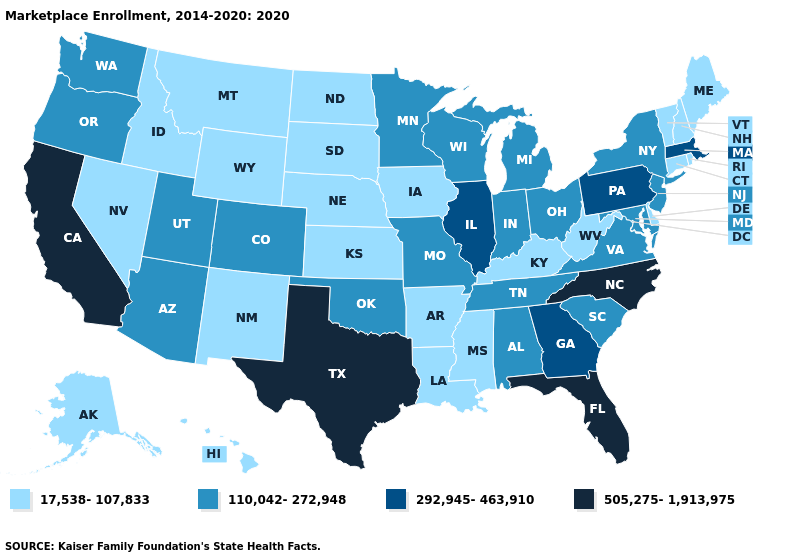Name the states that have a value in the range 505,275-1,913,975?
Answer briefly. California, Florida, North Carolina, Texas. Does the first symbol in the legend represent the smallest category?
Short answer required. Yes. Name the states that have a value in the range 17,538-107,833?
Answer briefly. Alaska, Arkansas, Connecticut, Delaware, Hawaii, Idaho, Iowa, Kansas, Kentucky, Louisiana, Maine, Mississippi, Montana, Nebraska, Nevada, New Hampshire, New Mexico, North Dakota, Rhode Island, South Dakota, Vermont, West Virginia, Wyoming. Among the states that border Wisconsin , does Iowa have the highest value?
Answer briefly. No. Name the states that have a value in the range 17,538-107,833?
Short answer required. Alaska, Arkansas, Connecticut, Delaware, Hawaii, Idaho, Iowa, Kansas, Kentucky, Louisiana, Maine, Mississippi, Montana, Nebraska, Nevada, New Hampshire, New Mexico, North Dakota, Rhode Island, South Dakota, Vermont, West Virginia, Wyoming. Among the states that border New Mexico , which have the lowest value?
Give a very brief answer. Arizona, Colorado, Oklahoma, Utah. Does Kentucky have the lowest value in the USA?
Short answer required. Yes. What is the highest value in the West ?
Concise answer only. 505,275-1,913,975. Does Ohio have the same value as South Dakota?
Be succinct. No. What is the lowest value in the Northeast?
Quick response, please. 17,538-107,833. What is the value of North Dakota?
Answer briefly. 17,538-107,833. Name the states that have a value in the range 292,945-463,910?
Concise answer only. Georgia, Illinois, Massachusetts, Pennsylvania. Among the states that border Florida , which have the lowest value?
Answer briefly. Alabama. 